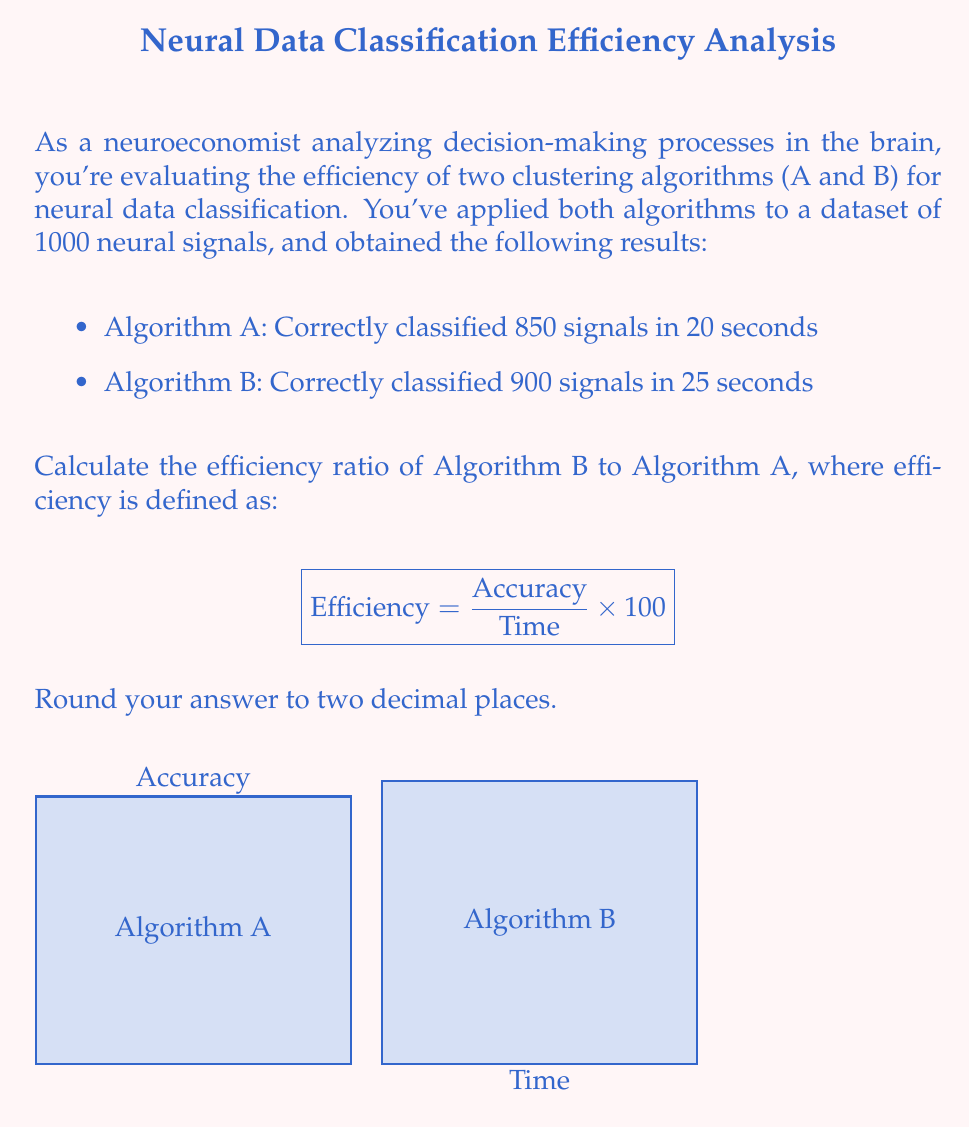Show me your answer to this math problem. Let's approach this step-by-step:

1) First, we need to calculate the efficiency for each algorithm using the given formula:

   $$ \text{Efficiency} = \frac{\text{Accuracy}}{\text{Time}} \times 100 $$

2) For Algorithm A:
   Accuracy = 850/1000 = 0.85
   Time = 20 seconds
   
   $$ \text{Efficiency}_A = \frac{0.85}{20} \times 100 = 4.25 $$

3) For Algorithm B:
   Accuracy = 900/1000 = 0.90
   Time = 25 seconds
   
   $$ \text{Efficiency}_B = \frac{0.90}{25} \times 100 = 3.60 $$

4) Now, to find the efficiency ratio of Algorithm B to Algorithm A, we divide the efficiency of B by the efficiency of A:

   $$ \text{Efficiency Ratio} = \frac{\text{Efficiency}_B}{\text{Efficiency}_A} = \frac{3.60}{4.25} \approx 0.8471 $$

5) Rounding to two decimal places, we get 0.85.
Answer: 0.85 